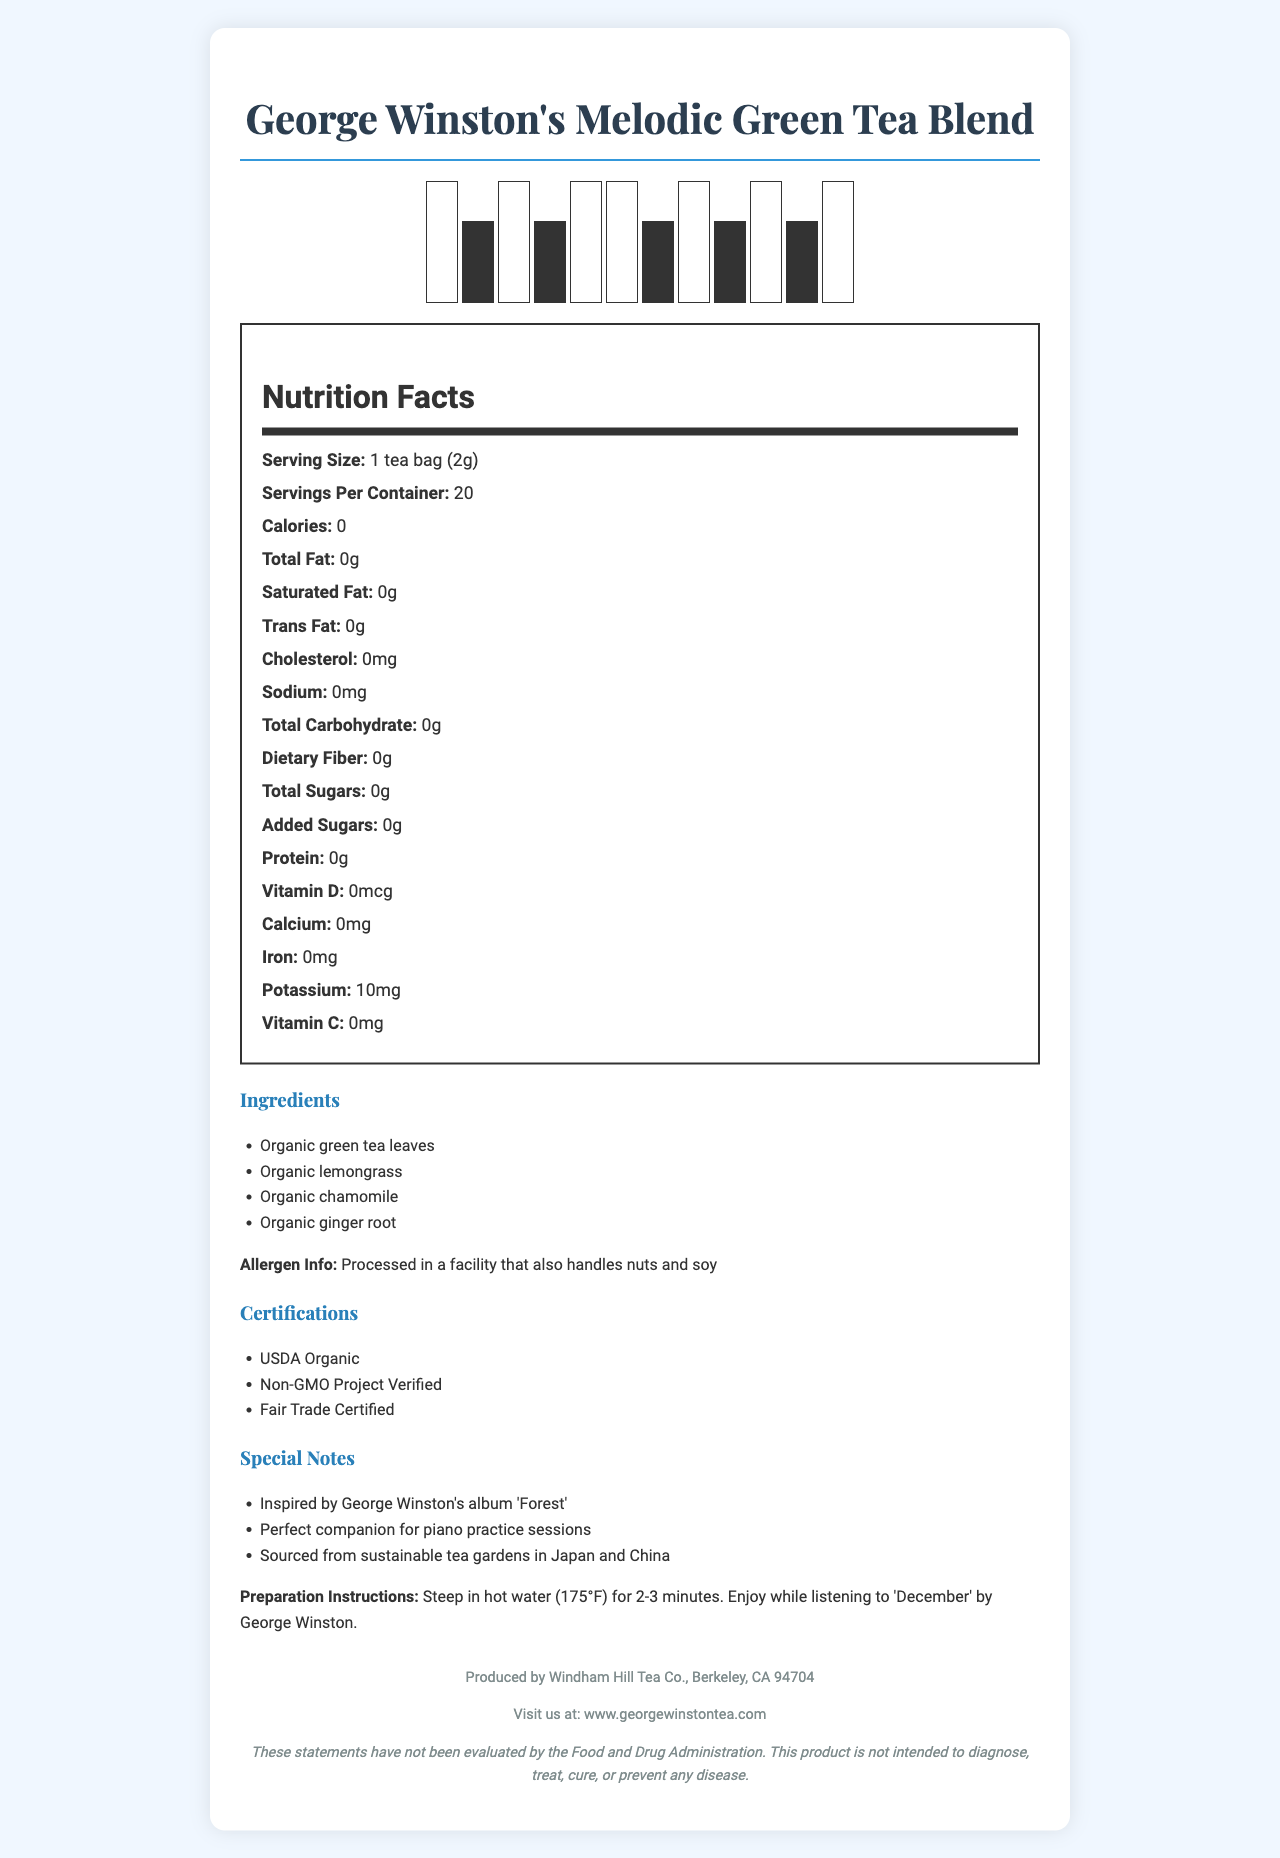What is the serving size of George Winston's Melodic Green Tea Blend? The serving size is specified as "1 tea bag (2g)" in the Nutrition Facts section.
Answer: 1 tea bag (2g) How many servings are in one container of the tea blend? The document states there are 20 servings per container.
Answer: 20 Does the tea contain any calories? The Nutrition Facts panel shows that the tea contains 0 calories.
Answer: No What are the organic ingredients listed in the tea blend? The ingredients section lists these organic ingredients.
Answer: Organic green tea leaves, Organic lemongrass, Organic chamomile, Organic ginger root Is the tea blend free of added sugars? The Nutrition Facts indicate 0g of added sugars.
Answer: Yes Which nutrient is present in the tea, and how much? According to the Nutrition Facts, the only nutrient present is potassium at 10mg.
Answer: Potassium, 10mg Which of the following certifications does the tea not have? A. USDA Organic B. Non-GMO Project Verified C. Fair Trade Certified D. Gluten-Free The certifications listed are USDA Organic, Non-GMO Project Verified, and Fair Trade Certified, but not Gluten-Free.
Answer: D. Gluten-Free Who produces George Winston's Melodic Green Tea Blend? A. Windham Hill Records B. Windham Hill Tea Co. C. George Winston Inc. D. Organic Tea Producers Ltd. The footer of the document says it is produced by Windham Hill Tea Co., Berkeley, CA 94704.
Answer: B. Windham Hill Tea Co. Can the preparation instructions for the tea be found in the document? The preparation instructions are to steep in hot water (175°F) for 2-3 minutes and enjoy while listening to 'December' by George Winston.
Answer: Yes Does the tea contain any allergens? The allergen information states the tea is processed in a facility that also handles nuts and soy.
Answer: Yes Summarize the main idea of the document. The document provides comprehensive information about George Winston's Melodic Green Tea Blend, including ingredients, nutrition facts, servings, allergens, certifications, special notes, and manufacturer details.
Answer: A detailed Nutrition Facts Label for George Winston's Melodic Green Tea Blend, including nutritional content, ingredients, certifications, special notes, preparation instructions, and manufacturer information. What are the health benefits of drinking this tea? The document does not provide any information about specific health benefits of drinking this tea.
Answer: Cannot be determined 